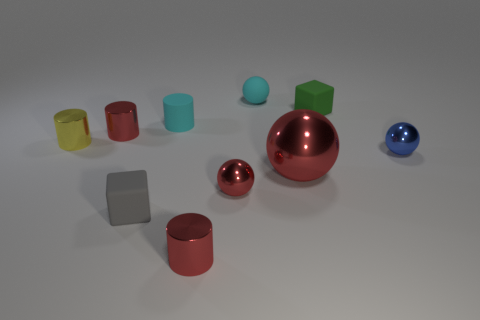How many gray things are either matte cylinders or small matte things?
Offer a terse response. 1. The tiny block to the left of the red cylinder in front of the blue metal thing is what color?
Keep it short and to the point. Gray. There is a thing that is the same color as the matte cylinder; what is its material?
Give a very brief answer. Rubber. The block that is to the right of the big shiny object is what color?
Provide a succinct answer. Green. There is a matte cube that is left of the green object; does it have the same size as the large object?
Your response must be concise. No. What is the size of the rubber ball that is the same color as the small matte cylinder?
Give a very brief answer. Small. Is there a green rubber block of the same size as the cyan cylinder?
Offer a very short reply. Yes. There is a cube that is behind the small yellow metal cylinder; is its color the same as the metal ball on the right side of the green rubber cube?
Provide a short and direct response. No. Are there any matte cylinders of the same color as the big metal ball?
Provide a succinct answer. No. How many other objects are the same shape as the small blue metallic object?
Offer a terse response. 3. 